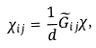Convert formula to latex. <formula><loc_0><loc_0><loc_500><loc_500>\chi _ { i j } = { \frac { 1 } { d } } { \widetilde { G } } _ { i j } \chi ,</formula> 